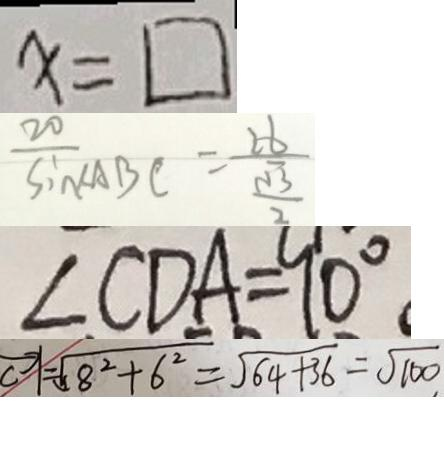<formula> <loc_0><loc_0><loc_500><loc_500>x = \square 
 \frac { 2 0 } { \sin \angle A B C } = \frac { 2 6 } { \frac { \sqrt { 3 } } { 2 } } 
 \angle C D A = 9 0 ^ { \circ } 
 \overrightarrow { \vert } = \sqrt { 8 ^ { 2 } + 6 ^ { 2 } } = \sqrt { 6 4 + 3 6 } = \sqrt { 1 0 0 }</formula> 